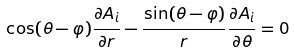<formula> <loc_0><loc_0><loc_500><loc_500>\cos ( \theta - \varphi ) \frac { \partial A _ { i } } { \partial r } - \frac { \sin ( \theta - \varphi ) } r \frac { \partial A _ { i } } { \partial \theta } = 0</formula> 